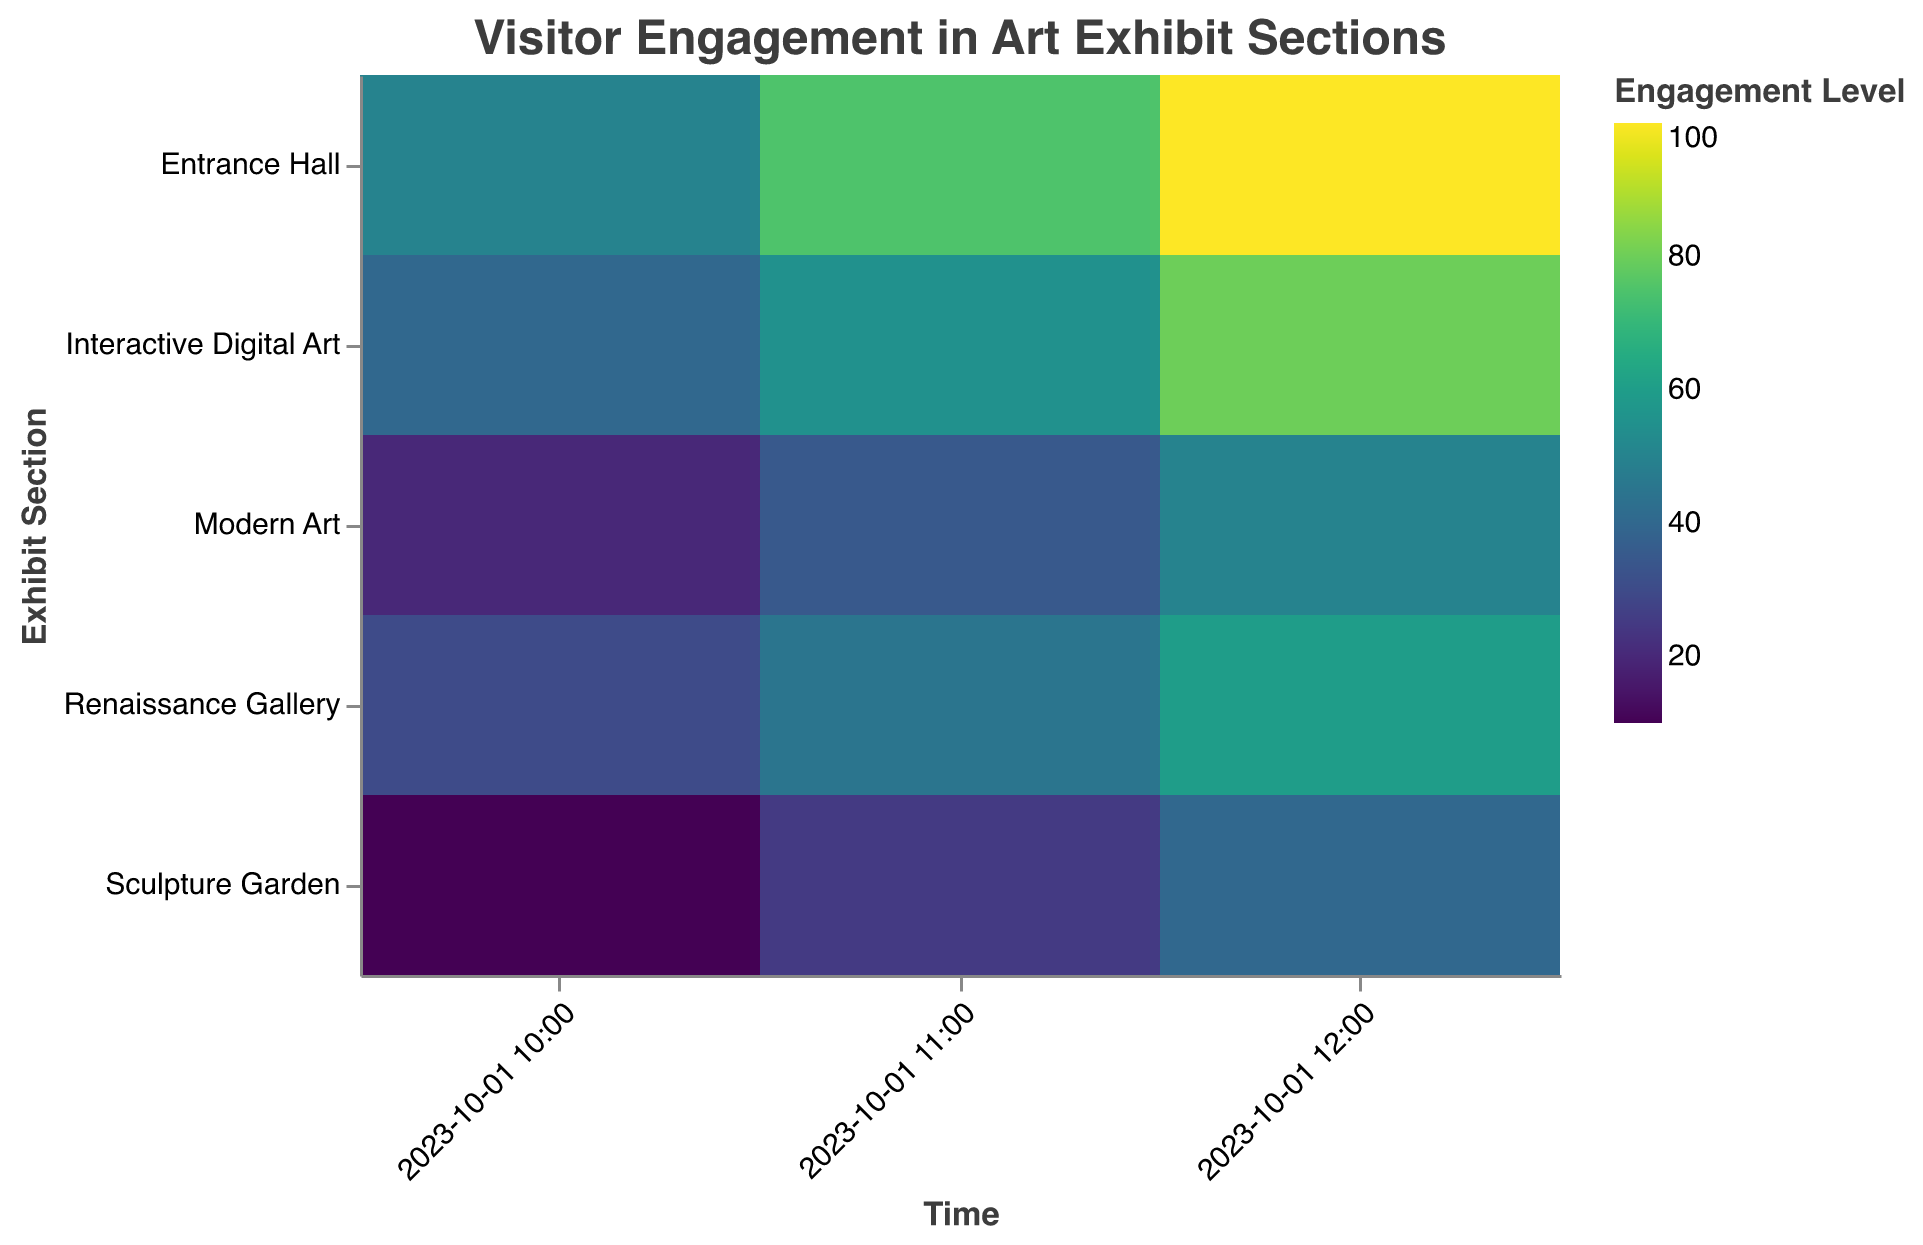What is the title of the heatmap? The title of the heatmap is written in the top middle of the figure and is in "Helvetica" font.
Answer: Visitor Engagement in Art Exhibit Sections Which section has the highest engagement level at 12:00? To find this, look at the column corresponding to 12:00 and identify the cell with the darkest color, indicating the highest engagement level.
Answer: Entrance Hall What color scheme is used for indicating engagement levels? The legend for engagement levels reveals the color scheme used, which is "viridis".
Answer: viridis How does the engagement level in the Entrance Hall change from 10:00 to 12:00? Track the Engagement Hall row from 10:00 to 12:00. Note the color progression and the numbers: 50 at 10:00, 75 at 11:00, and 100 at 12:00, reflecting increasing engagement.
Answer: It increases Compare the engagement levels at 11:00 in the Modern Art section and the Sculpture Garden. Which one is higher? Look at the 11:00 time slot for both Modern Art and Sculpture Garden. Modern Art has an engagement level of 35, while Sculpture Garden has 25.
Answer: Modern Art Which sections have the lowest engagement level at 10:00? Scan the 10:00 column for the lightest colors and lowest numbers, identifying Sculpture Garden with an engagement level of 10.
Answer: Sculpture Garden What is the average engagement level for Renaissance Gallery over the given time periods? Sum the engagement levels for Renaissance Gallery at each time point (30 + 45 + 60) and divide by the number of time points (3). Hence, (30 + 45 + 60)/3 = 135/3.
Answer: 45 Do engagement levels in Interactive Digital Art show a significant increase over time? Observe the change in engagement level for Interactive Digital Art from 10:00 to 12:00: 40, 55, and 80, respectively, showing a consistent increase.
Answer: Yes Which section shows the most consistent engagement level over time? Examine the fluctuation in engagement levels for each section. Renaissance Gallery changes from 30 to 45 to 60, showing the most consistent incremental increase.
Answer: Renaissance Gallery 